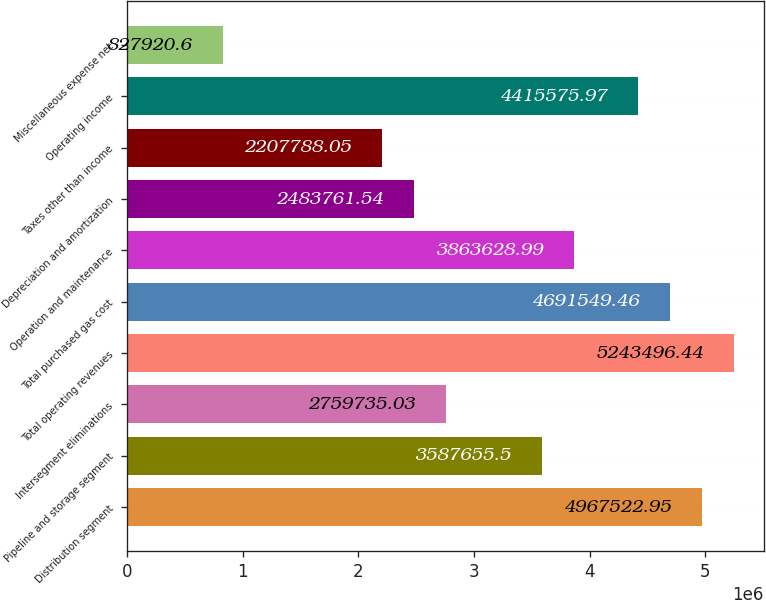Convert chart to OTSL. <chart><loc_0><loc_0><loc_500><loc_500><bar_chart><fcel>Distribution segment<fcel>Pipeline and storage segment<fcel>Intersegment eliminations<fcel>Total operating revenues<fcel>Total purchased gas cost<fcel>Operation and maintenance<fcel>Depreciation and amortization<fcel>Taxes other than income<fcel>Operating income<fcel>Miscellaneous expense net<nl><fcel>4.96752e+06<fcel>3.58766e+06<fcel>2.75974e+06<fcel>5.2435e+06<fcel>4.69155e+06<fcel>3.86363e+06<fcel>2.48376e+06<fcel>2.20779e+06<fcel>4.41558e+06<fcel>827921<nl></chart> 